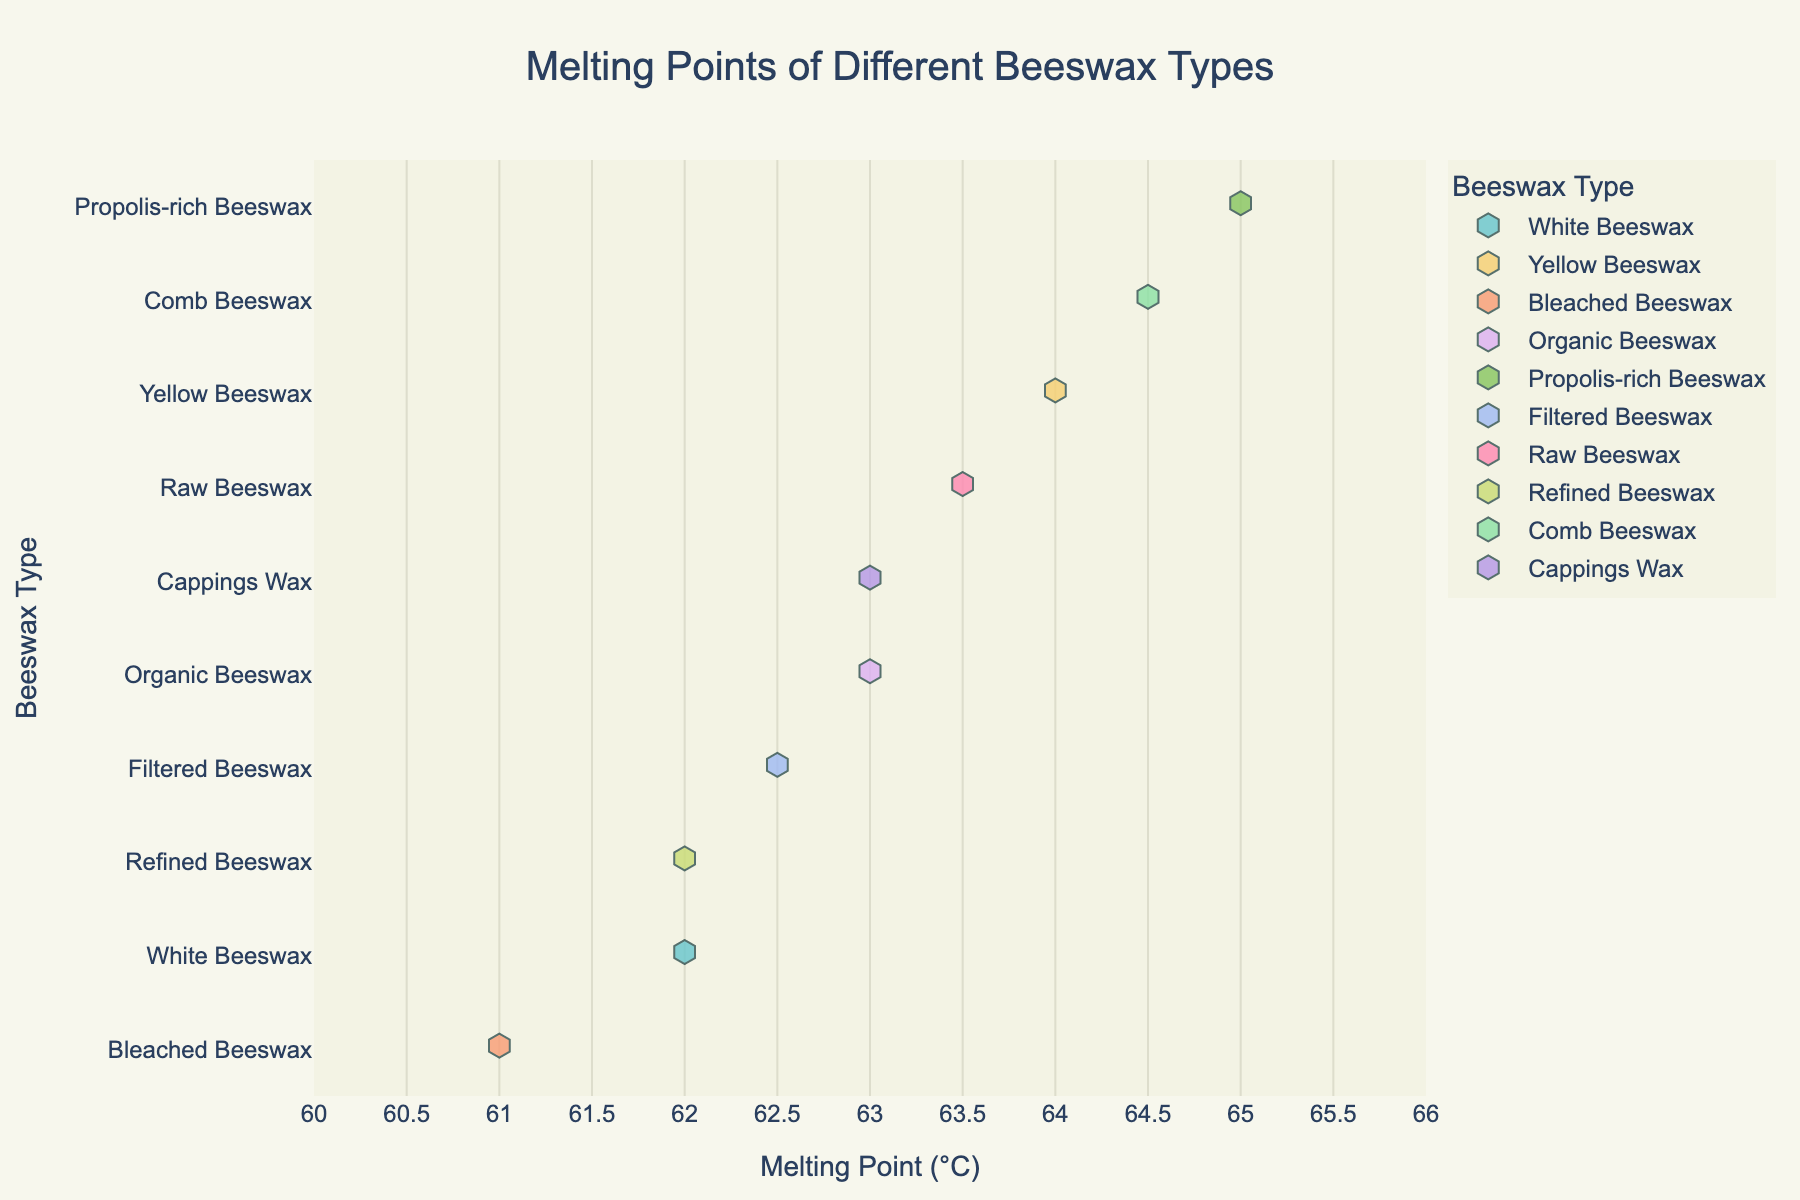What's the title of the figure? The title is usually displayed at the top of the plot, setting the context for what the data represents.
Answer: Melting Points of Different Beeswax Types What are the types of beeswax shown in the plot? The beeswax types are listed on the y-axis of the plot.
Answer: White Beeswax, Yellow Beeswax, Bleached Beeswax, Organic Beeswax, Propolis-rich Beeswax, Filtered Beeswax, Raw Beeswax, Refined Beeswax, Comb Beeswax, Cappings Wax Which type of beeswax has the highest melting point? The melting points are shown on the x-axis. The highest value should be identified.
Answer: Propolis-rich Beeswax What is the range of melting points for the beeswax types? The range is the difference between the highest and lowest melting points on the x-axis.
Answer: 61°C to 65°C What is the melting point of Bleached Beeswax? Find the point on the plot corresponding to Bleached Beeswax and note the x-axis value.
Answer: 61°C Which beeswax types have the same melting point of 62°C? Identify all beeswax types whose data points are at 62°C on the x-axis.
Answer: White Beeswax, Refined Beeswax How many types of beeswax have melting points above 63°C? Count the beeswax types whose data points are above 63°C on the x-axis.
Answer: 5 What is the average melting point of Organic Beeswax and Raw Beeswax? Add the melting points of Organic Beeswax and Raw Beeswax, then divide by 2. 63°C + 63.5°C = 126.5, then divide by 2.
Answer: 63.25°C Which beeswax type has a melting point closest to 64°C? Find the beeswax type whose data point is nearest to 64 on the x-axis.
Answer: Yellow Beeswax Which beeswax types have melting points within the range of 62 to 63°C? Identify all types with melting points between 62 and 63°C on the x-axis.
Answer: White Beeswax, Filtered Beeswax, Organic Beeswax, Refined Beeswax, Cappings Wax 